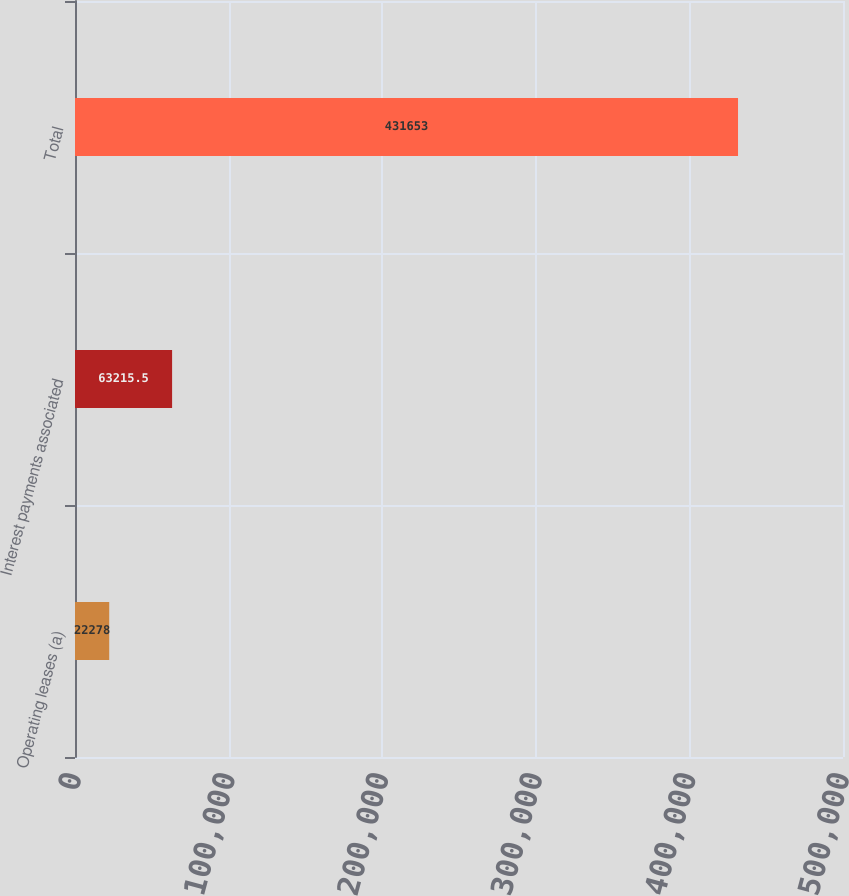<chart> <loc_0><loc_0><loc_500><loc_500><bar_chart><fcel>Operating leases (a)<fcel>Interest payments associated<fcel>Total<nl><fcel>22278<fcel>63215.5<fcel>431653<nl></chart> 